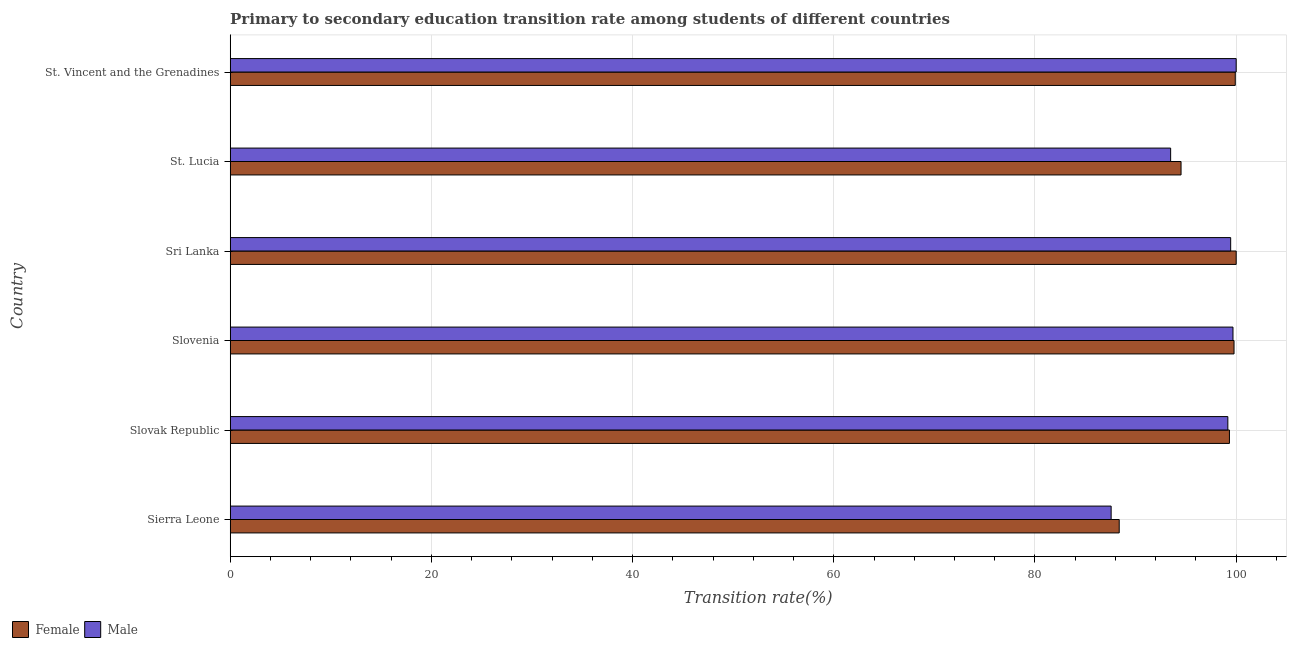How many different coloured bars are there?
Offer a terse response. 2. How many groups of bars are there?
Your answer should be very brief. 6. Are the number of bars on each tick of the Y-axis equal?
Provide a short and direct response. Yes. How many bars are there on the 6th tick from the top?
Make the answer very short. 2. How many bars are there on the 4th tick from the bottom?
Provide a short and direct response. 2. What is the label of the 3rd group of bars from the top?
Give a very brief answer. Sri Lanka. What is the transition rate among female students in Sri Lanka?
Your answer should be compact. 100. Across all countries, what is the maximum transition rate among female students?
Your response must be concise. 100. Across all countries, what is the minimum transition rate among male students?
Your response must be concise. 87.57. In which country was the transition rate among female students maximum?
Provide a short and direct response. Sri Lanka. In which country was the transition rate among female students minimum?
Your response must be concise. Sierra Leone. What is the total transition rate among male students in the graph?
Your answer should be compact. 579.36. What is the difference between the transition rate among female students in Slovak Republic and that in Sri Lanka?
Provide a succinct answer. -0.67. What is the difference between the transition rate among female students in St. Lucia and the transition rate among male students in Sierra Leone?
Ensure brevity in your answer.  6.95. What is the average transition rate among female students per country?
Keep it short and to the point. 96.98. What is the difference between the transition rate among female students and transition rate among male students in Sierra Leone?
Offer a very short reply. 0.8. In how many countries, is the transition rate among male students greater than 8 %?
Your answer should be very brief. 6. What is the ratio of the transition rate among female students in Sierra Leone to that in Slovenia?
Provide a succinct answer. 0.89. What is the difference between the highest and the second highest transition rate among female students?
Your answer should be very brief. 0.09. What is the difference between the highest and the lowest transition rate among female students?
Keep it short and to the point. 11.63. In how many countries, is the transition rate among female students greater than the average transition rate among female students taken over all countries?
Your answer should be very brief. 4. Is the sum of the transition rate among female students in Sri Lanka and St. Vincent and the Grenadines greater than the maximum transition rate among male students across all countries?
Keep it short and to the point. Yes. What does the 1st bar from the bottom in Sierra Leone represents?
Your answer should be very brief. Female. Are all the bars in the graph horizontal?
Provide a short and direct response. Yes. What is the difference between two consecutive major ticks on the X-axis?
Give a very brief answer. 20. Does the graph contain any zero values?
Ensure brevity in your answer.  No. Does the graph contain grids?
Offer a very short reply. Yes. Where does the legend appear in the graph?
Offer a terse response. Bottom left. How many legend labels are there?
Your answer should be very brief. 2. How are the legend labels stacked?
Your answer should be compact. Horizontal. What is the title of the graph?
Your answer should be compact. Primary to secondary education transition rate among students of different countries. What is the label or title of the X-axis?
Ensure brevity in your answer.  Transition rate(%). What is the label or title of the Y-axis?
Ensure brevity in your answer.  Country. What is the Transition rate(%) in Female in Sierra Leone?
Give a very brief answer. 88.37. What is the Transition rate(%) in Male in Sierra Leone?
Make the answer very short. 87.57. What is the Transition rate(%) in Female in Slovak Republic?
Provide a short and direct response. 99.33. What is the Transition rate(%) in Male in Slovak Republic?
Offer a very short reply. 99.17. What is the Transition rate(%) in Female in Slovenia?
Ensure brevity in your answer.  99.79. What is the Transition rate(%) of Male in Slovenia?
Ensure brevity in your answer.  99.68. What is the Transition rate(%) in Male in Sri Lanka?
Ensure brevity in your answer.  99.45. What is the Transition rate(%) of Female in St. Lucia?
Your response must be concise. 94.52. What is the Transition rate(%) of Male in St. Lucia?
Provide a short and direct response. 93.48. What is the Transition rate(%) in Female in St. Vincent and the Grenadines?
Ensure brevity in your answer.  99.91. What is the Transition rate(%) in Male in St. Vincent and the Grenadines?
Your response must be concise. 100. Across all countries, what is the maximum Transition rate(%) of Female?
Your answer should be very brief. 100. Across all countries, what is the maximum Transition rate(%) of Male?
Give a very brief answer. 100. Across all countries, what is the minimum Transition rate(%) of Female?
Offer a very short reply. 88.37. Across all countries, what is the minimum Transition rate(%) of Male?
Keep it short and to the point. 87.57. What is the total Transition rate(%) in Female in the graph?
Your answer should be compact. 581.91. What is the total Transition rate(%) in Male in the graph?
Your response must be concise. 579.36. What is the difference between the Transition rate(%) in Female in Sierra Leone and that in Slovak Republic?
Your answer should be compact. -10.96. What is the difference between the Transition rate(%) in Male in Sierra Leone and that in Slovak Republic?
Offer a very short reply. -11.6. What is the difference between the Transition rate(%) of Female in Sierra Leone and that in Slovenia?
Provide a succinct answer. -11.41. What is the difference between the Transition rate(%) in Male in Sierra Leone and that in Slovenia?
Provide a succinct answer. -12.11. What is the difference between the Transition rate(%) of Female in Sierra Leone and that in Sri Lanka?
Your answer should be compact. -11.63. What is the difference between the Transition rate(%) in Male in Sierra Leone and that in Sri Lanka?
Provide a short and direct response. -11.88. What is the difference between the Transition rate(%) of Female in Sierra Leone and that in St. Lucia?
Make the answer very short. -6.15. What is the difference between the Transition rate(%) of Male in Sierra Leone and that in St. Lucia?
Give a very brief answer. -5.91. What is the difference between the Transition rate(%) in Female in Sierra Leone and that in St. Vincent and the Grenadines?
Your answer should be compact. -11.53. What is the difference between the Transition rate(%) in Male in Sierra Leone and that in St. Vincent and the Grenadines?
Make the answer very short. -12.43. What is the difference between the Transition rate(%) of Female in Slovak Republic and that in Slovenia?
Offer a terse response. -0.46. What is the difference between the Transition rate(%) of Male in Slovak Republic and that in Slovenia?
Provide a short and direct response. -0.51. What is the difference between the Transition rate(%) of Female in Slovak Republic and that in Sri Lanka?
Make the answer very short. -0.67. What is the difference between the Transition rate(%) of Male in Slovak Republic and that in Sri Lanka?
Make the answer very short. -0.28. What is the difference between the Transition rate(%) of Female in Slovak Republic and that in St. Lucia?
Provide a short and direct response. 4.81. What is the difference between the Transition rate(%) in Male in Slovak Republic and that in St. Lucia?
Offer a terse response. 5.69. What is the difference between the Transition rate(%) in Female in Slovak Republic and that in St. Vincent and the Grenadines?
Provide a succinct answer. -0.58. What is the difference between the Transition rate(%) in Male in Slovak Republic and that in St. Vincent and the Grenadines?
Your response must be concise. -0.83. What is the difference between the Transition rate(%) of Female in Slovenia and that in Sri Lanka?
Offer a terse response. -0.21. What is the difference between the Transition rate(%) of Male in Slovenia and that in Sri Lanka?
Make the answer very short. 0.23. What is the difference between the Transition rate(%) in Female in Slovenia and that in St. Lucia?
Ensure brevity in your answer.  5.27. What is the difference between the Transition rate(%) of Male in Slovenia and that in St. Lucia?
Your response must be concise. 6.2. What is the difference between the Transition rate(%) of Female in Slovenia and that in St. Vincent and the Grenadines?
Give a very brief answer. -0.12. What is the difference between the Transition rate(%) of Male in Slovenia and that in St. Vincent and the Grenadines?
Offer a terse response. -0.32. What is the difference between the Transition rate(%) in Female in Sri Lanka and that in St. Lucia?
Keep it short and to the point. 5.48. What is the difference between the Transition rate(%) in Male in Sri Lanka and that in St. Lucia?
Provide a succinct answer. 5.97. What is the difference between the Transition rate(%) of Female in Sri Lanka and that in St. Vincent and the Grenadines?
Keep it short and to the point. 0.09. What is the difference between the Transition rate(%) of Male in Sri Lanka and that in St. Vincent and the Grenadines?
Offer a very short reply. -0.55. What is the difference between the Transition rate(%) in Female in St. Lucia and that in St. Vincent and the Grenadines?
Your answer should be very brief. -5.39. What is the difference between the Transition rate(%) of Male in St. Lucia and that in St. Vincent and the Grenadines?
Offer a terse response. -6.52. What is the difference between the Transition rate(%) in Female in Sierra Leone and the Transition rate(%) in Male in Slovak Republic?
Your answer should be very brief. -10.8. What is the difference between the Transition rate(%) in Female in Sierra Leone and the Transition rate(%) in Male in Slovenia?
Keep it short and to the point. -11.31. What is the difference between the Transition rate(%) of Female in Sierra Leone and the Transition rate(%) of Male in Sri Lanka?
Provide a short and direct response. -11.08. What is the difference between the Transition rate(%) of Female in Sierra Leone and the Transition rate(%) of Male in St. Lucia?
Provide a succinct answer. -5.11. What is the difference between the Transition rate(%) of Female in Sierra Leone and the Transition rate(%) of Male in St. Vincent and the Grenadines?
Offer a terse response. -11.63. What is the difference between the Transition rate(%) of Female in Slovak Republic and the Transition rate(%) of Male in Slovenia?
Provide a succinct answer. -0.35. What is the difference between the Transition rate(%) of Female in Slovak Republic and the Transition rate(%) of Male in Sri Lanka?
Provide a succinct answer. -0.12. What is the difference between the Transition rate(%) in Female in Slovak Republic and the Transition rate(%) in Male in St. Lucia?
Make the answer very short. 5.84. What is the difference between the Transition rate(%) in Female in Slovak Republic and the Transition rate(%) in Male in St. Vincent and the Grenadines?
Provide a short and direct response. -0.67. What is the difference between the Transition rate(%) in Female in Slovenia and the Transition rate(%) in Male in Sri Lanka?
Offer a very short reply. 0.33. What is the difference between the Transition rate(%) of Female in Slovenia and the Transition rate(%) of Male in St. Lucia?
Keep it short and to the point. 6.3. What is the difference between the Transition rate(%) in Female in Slovenia and the Transition rate(%) in Male in St. Vincent and the Grenadines?
Your response must be concise. -0.21. What is the difference between the Transition rate(%) of Female in Sri Lanka and the Transition rate(%) of Male in St. Lucia?
Provide a succinct answer. 6.52. What is the difference between the Transition rate(%) in Female in St. Lucia and the Transition rate(%) in Male in St. Vincent and the Grenadines?
Offer a terse response. -5.48. What is the average Transition rate(%) in Female per country?
Offer a terse response. 96.99. What is the average Transition rate(%) in Male per country?
Your answer should be compact. 96.56. What is the difference between the Transition rate(%) of Female and Transition rate(%) of Male in Sierra Leone?
Make the answer very short. 0.8. What is the difference between the Transition rate(%) of Female and Transition rate(%) of Male in Slovak Republic?
Give a very brief answer. 0.16. What is the difference between the Transition rate(%) in Female and Transition rate(%) in Male in Slovenia?
Ensure brevity in your answer.  0.1. What is the difference between the Transition rate(%) in Female and Transition rate(%) in Male in Sri Lanka?
Offer a very short reply. 0.55. What is the difference between the Transition rate(%) in Female and Transition rate(%) in Male in St. Lucia?
Your answer should be compact. 1.03. What is the difference between the Transition rate(%) of Female and Transition rate(%) of Male in St. Vincent and the Grenadines?
Your answer should be very brief. -0.09. What is the ratio of the Transition rate(%) in Female in Sierra Leone to that in Slovak Republic?
Make the answer very short. 0.89. What is the ratio of the Transition rate(%) in Male in Sierra Leone to that in Slovak Republic?
Provide a succinct answer. 0.88. What is the ratio of the Transition rate(%) of Female in Sierra Leone to that in Slovenia?
Provide a succinct answer. 0.89. What is the ratio of the Transition rate(%) in Male in Sierra Leone to that in Slovenia?
Offer a terse response. 0.88. What is the ratio of the Transition rate(%) of Female in Sierra Leone to that in Sri Lanka?
Your answer should be very brief. 0.88. What is the ratio of the Transition rate(%) in Male in Sierra Leone to that in Sri Lanka?
Keep it short and to the point. 0.88. What is the ratio of the Transition rate(%) in Female in Sierra Leone to that in St. Lucia?
Ensure brevity in your answer.  0.94. What is the ratio of the Transition rate(%) in Male in Sierra Leone to that in St. Lucia?
Provide a short and direct response. 0.94. What is the ratio of the Transition rate(%) in Female in Sierra Leone to that in St. Vincent and the Grenadines?
Ensure brevity in your answer.  0.88. What is the ratio of the Transition rate(%) in Male in Sierra Leone to that in St. Vincent and the Grenadines?
Give a very brief answer. 0.88. What is the ratio of the Transition rate(%) in Female in Slovak Republic to that in Slovenia?
Make the answer very short. 1. What is the ratio of the Transition rate(%) of Male in Slovak Republic to that in Sri Lanka?
Keep it short and to the point. 1. What is the ratio of the Transition rate(%) in Female in Slovak Republic to that in St. Lucia?
Provide a short and direct response. 1.05. What is the ratio of the Transition rate(%) of Male in Slovak Republic to that in St. Lucia?
Keep it short and to the point. 1.06. What is the ratio of the Transition rate(%) of Male in Slovak Republic to that in St. Vincent and the Grenadines?
Your answer should be very brief. 0.99. What is the ratio of the Transition rate(%) of Female in Slovenia to that in St. Lucia?
Provide a succinct answer. 1.06. What is the ratio of the Transition rate(%) in Male in Slovenia to that in St. Lucia?
Offer a very short reply. 1.07. What is the ratio of the Transition rate(%) of Female in Slovenia to that in St. Vincent and the Grenadines?
Your answer should be very brief. 1. What is the ratio of the Transition rate(%) in Female in Sri Lanka to that in St. Lucia?
Provide a short and direct response. 1.06. What is the ratio of the Transition rate(%) of Male in Sri Lanka to that in St. Lucia?
Your response must be concise. 1.06. What is the ratio of the Transition rate(%) in Female in St. Lucia to that in St. Vincent and the Grenadines?
Offer a terse response. 0.95. What is the ratio of the Transition rate(%) of Male in St. Lucia to that in St. Vincent and the Grenadines?
Keep it short and to the point. 0.93. What is the difference between the highest and the second highest Transition rate(%) of Female?
Make the answer very short. 0.09. What is the difference between the highest and the second highest Transition rate(%) in Male?
Ensure brevity in your answer.  0.32. What is the difference between the highest and the lowest Transition rate(%) of Female?
Your answer should be compact. 11.63. What is the difference between the highest and the lowest Transition rate(%) of Male?
Give a very brief answer. 12.43. 